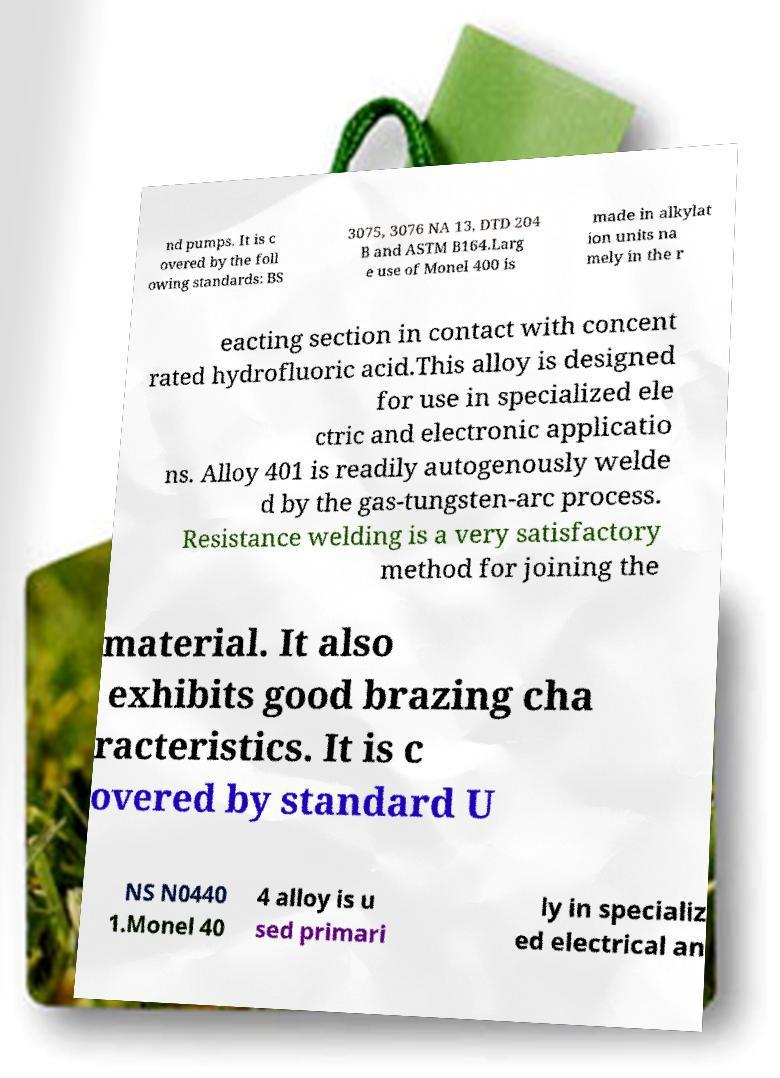Please identify and transcribe the text found in this image. nd pumps. It is c overed by the foll owing standards: BS 3075, 3076 NA 13, DTD 204 B and ASTM B164.Larg e use of Monel 400 is made in alkylat ion units na mely in the r eacting section in contact with concent rated hydrofluoric acid.This alloy is designed for use in specialized ele ctric and electronic applicatio ns. Alloy 401 is readily autogenously welde d by the gas-tungsten-arc process. Resistance welding is a very satisfactory method for joining the material. It also exhibits good brazing cha racteristics. It is c overed by standard U NS N0440 1.Monel 40 4 alloy is u sed primari ly in specializ ed electrical an 